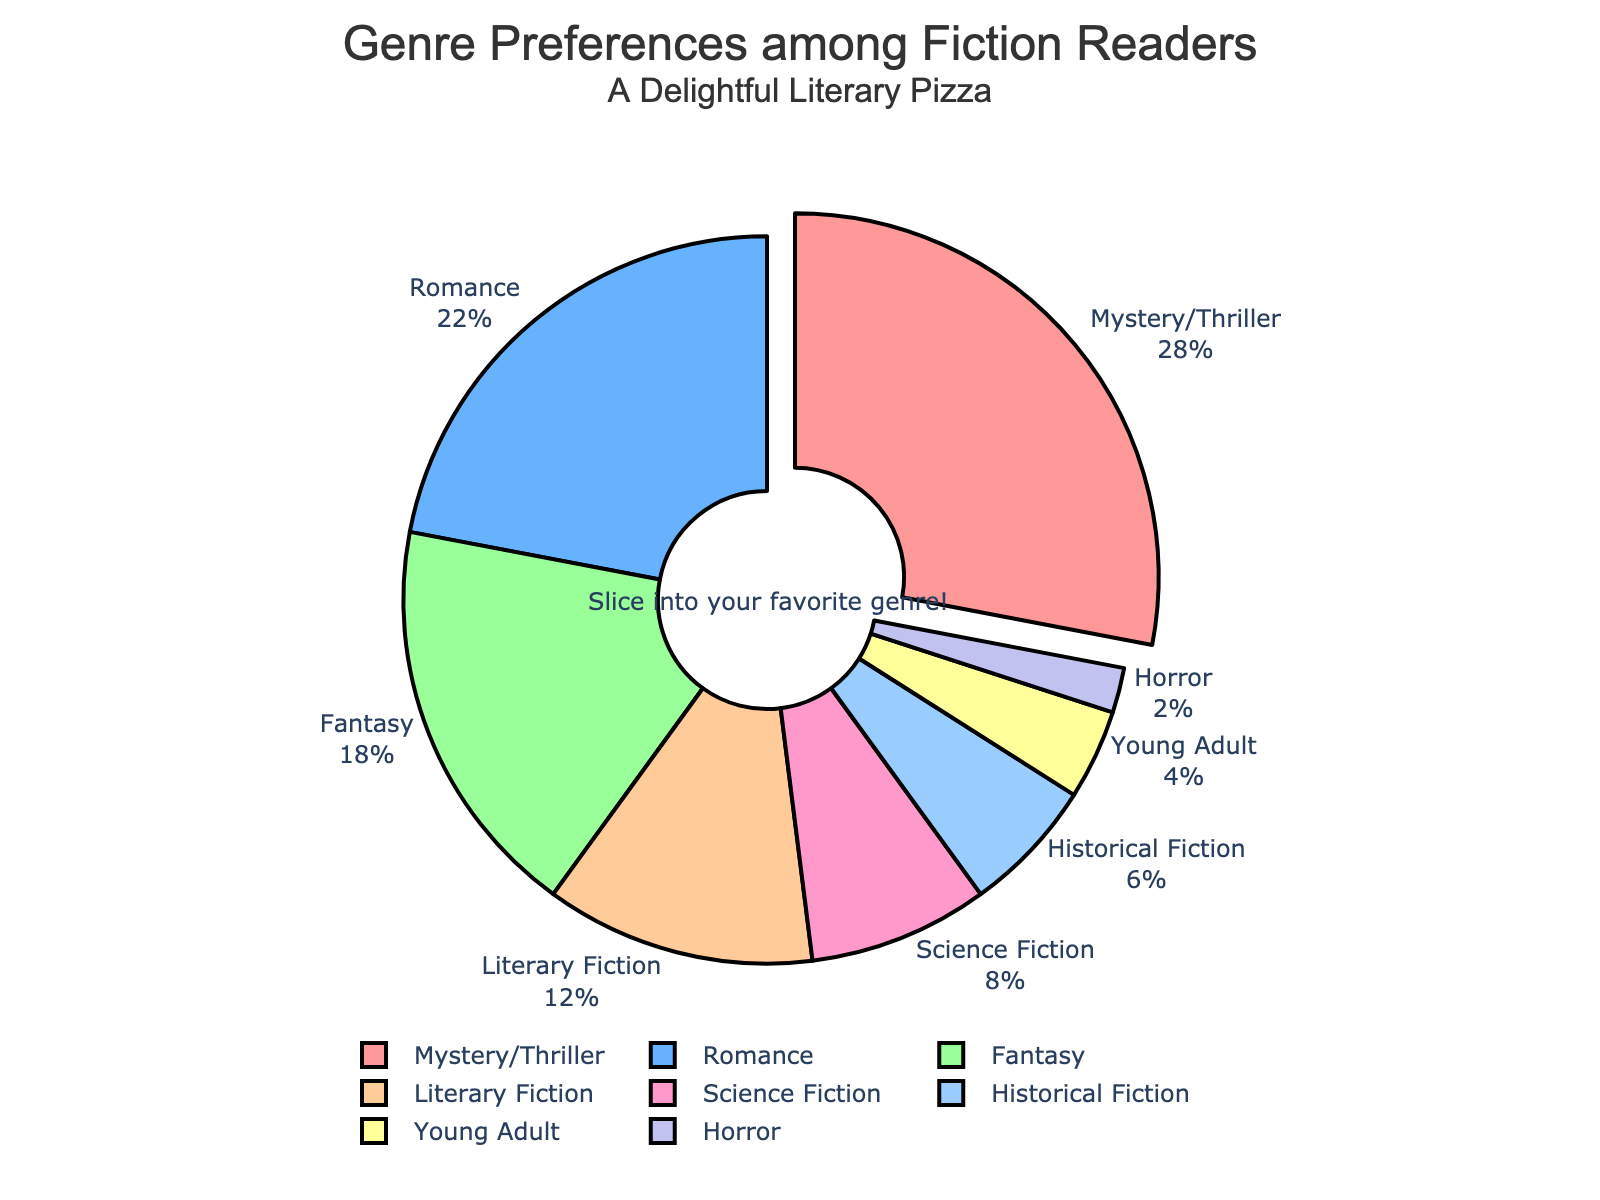What genre do the highest percentage of readers prefer? The slice that is "pulled" or slightly separated from the pie represents the genre with the highest percentage. This is "Mystery/Thriller" which has 28%.
Answer: Mystery/Thriller Which genre has the smallest percentage of readers? The smallest slice of the pie represents the genre with the smallest percentage of readers. This slice is labeled "Horror" and signifies 2%.
Answer: Horror Which two genres together account for exactly half (50%) of the readers' preferences? The percentages for "Mystery/Thriller" (28%) and "Romance" (22%) add up to 50%. Adding these together verifies this: 28 + 22 = 50.
Answer: Mystery/Thriller and Romance How much more popular is Mystery/Thriller than Horror? To find this, subtract the percentage of "Horror" (2%) from "Mystery/Thriller" (28%). So, 28 - 2 = 26.
Answer: 26% What percentage of readers prefer genres other than Mystery/Thriller, Romance, and Fantasy combined? Adding the percentages for Mystery/Thriller (28%), Romance (22%), and Fantasy (18%) gives 68%. Subtract this from 100% to find the remaining percentage which is 100 - 68 = 32.
Answer: 32% Compare the popularity between Fantasy and Science Fiction. By what factor is Fantasy preferred over Science Fiction? Fantasy has 18%, and Science Fiction has 8%. To find the factor, divide the percentage of Fantasy by Science Fiction: 18 / 8 = 2.25. Fantasy is 2.25 times more popular than Science Fiction.
Answer: 2.25 Which genres have a combined percentage lower than Literary Fiction's? Literary Fiction has 12%. Adding percentages of genres that are below this and verifying: Science Fiction (8%) + Young Adult (4%) + Horror (2%) sums up to 14%, which is not less than 12%. Only Historical Fiction (6%) and Horror (2%) combined give 6 + 2 = 8, which is lower.
Answer: Historical Fiction and Horror How does the popularity of Romance compare to the total of the least three preferred genres? Least three genres are Historical Fiction (6%), Young Adult (4%), and Horror (2%), summing up to 6 + 4 + 2 = 12%. Romance is at 22%, making it 10% more popular.
Answer: 10% Estimate the total percentage of readers that prefer genres targeted more at younger audiences (Young Adult and Fantasy). Adding percentages for Young Adult (4%) and Fantasy (18%) gives an estimated total of 4 + 18 = 22%.
Answer: 22% What color indicates the percentage of readers preferring Romance in the pie chart? The color associated with the Romance slice in the pie chart is "light blue" (#66B2FF).
Answer: Light Blue 